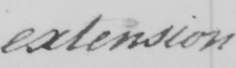Transcribe the text shown in this historical manuscript line. extension 